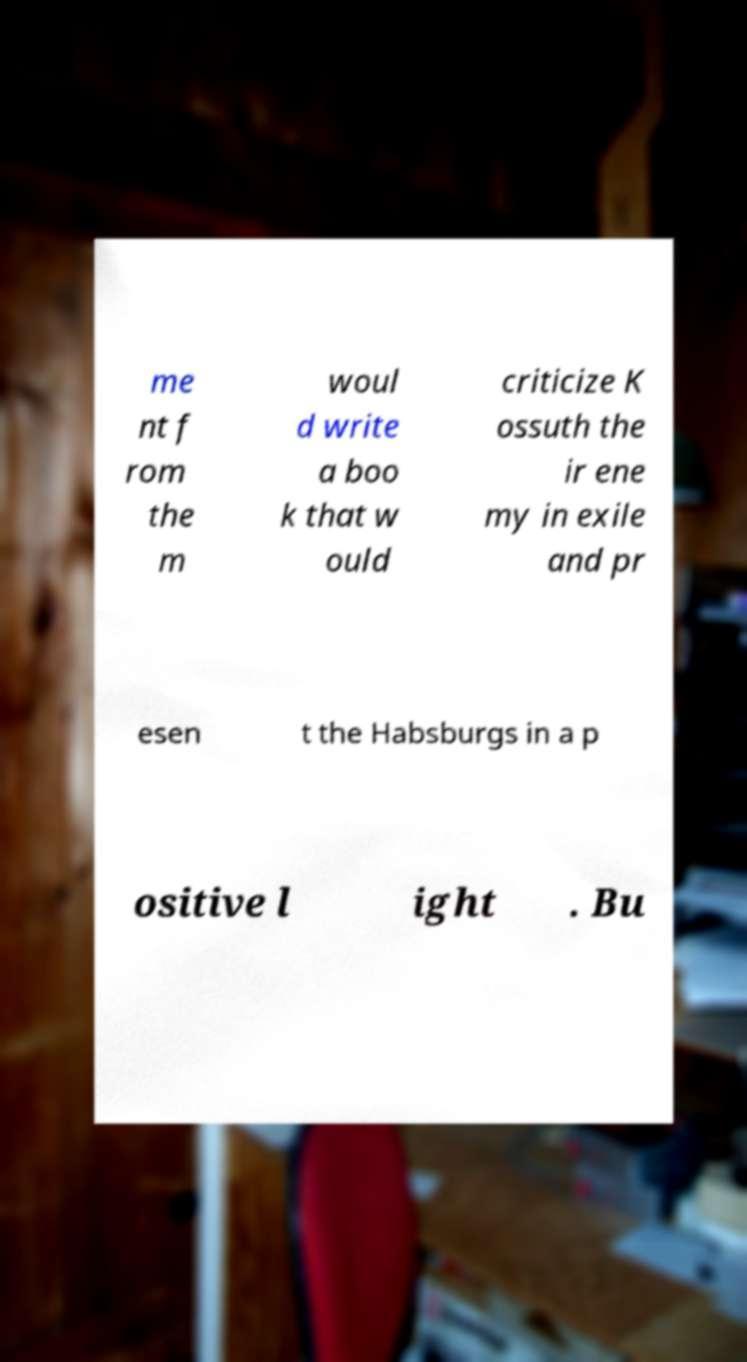Could you assist in decoding the text presented in this image and type it out clearly? me nt f rom the m woul d write a boo k that w ould criticize K ossuth the ir ene my in exile and pr esen t the Habsburgs in a p ositive l ight . Bu 